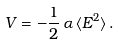Convert formula to latex. <formula><loc_0><loc_0><loc_500><loc_500>V = - \frac { 1 } { 2 } \, \alpha \, \langle { E } ^ { 2 } \rangle \, .</formula> 